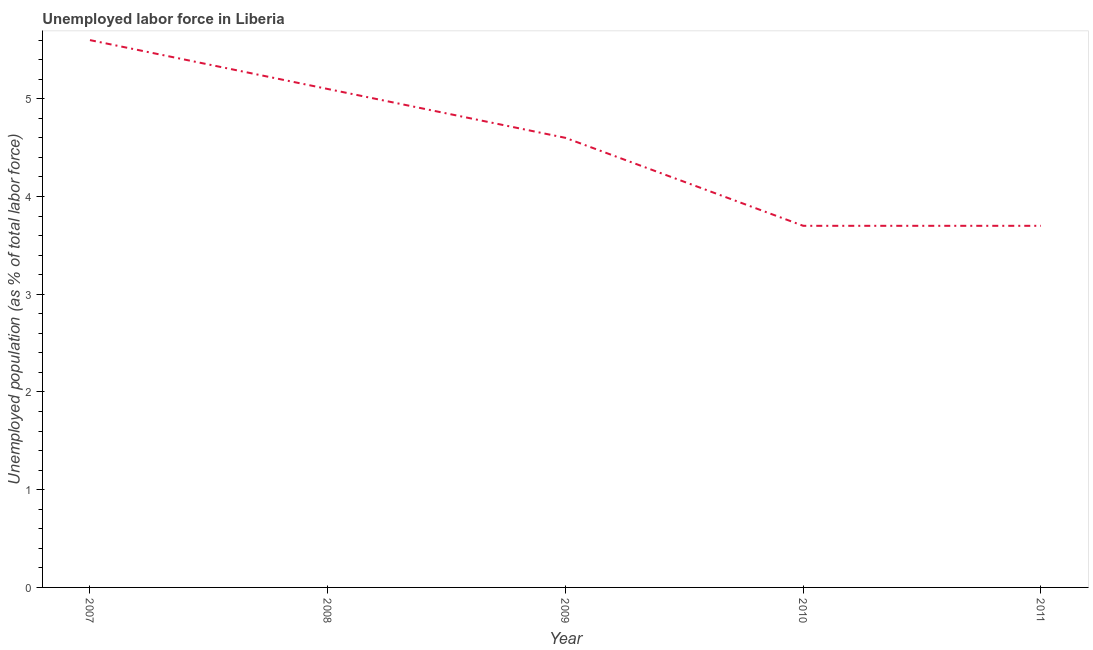What is the total unemployed population in 2009?
Provide a short and direct response. 4.6. Across all years, what is the maximum total unemployed population?
Give a very brief answer. 5.6. Across all years, what is the minimum total unemployed population?
Your answer should be compact. 3.7. What is the sum of the total unemployed population?
Keep it short and to the point. 22.7. What is the difference between the total unemployed population in 2007 and 2009?
Make the answer very short. 1. What is the average total unemployed population per year?
Make the answer very short. 4.54. What is the median total unemployed population?
Ensure brevity in your answer.  4.6. In how many years, is the total unemployed population greater than 4 %?
Your response must be concise. 3. What is the ratio of the total unemployed population in 2007 to that in 2010?
Provide a succinct answer. 1.51. What is the difference between the highest and the second highest total unemployed population?
Provide a short and direct response. 0.5. Is the sum of the total unemployed population in 2010 and 2011 greater than the maximum total unemployed population across all years?
Offer a terse response. Yes. What is the difference between the highest and the lowest total unemployed population?
Your response must be concise. 1.9. In how many years, is the total unemployed population greater than the average total unemployed population taken over all years?
Your response must be concise. 3. Are the values on the major ticks of Y-axis written in scientific E-notation?
Your answer should be compact. No. Does the graph contain grids?
Offer a very short reply. No. What is the title of the graph?
Offer a very short reply. Unemployed labor force in Liberia. What is the label or title of the Y-axis?
Make the answer very short. Unemployed population (as % of total labor force). What is the Unemployed population (as % of total labor force) of 2007?
Your response must be concise. 5.6. What is the Unemployed population (as % of total labor force) in 2008?
Provide a short and direct response. 5.1. What is the Unemployed population (as % of total labor force) of 2009?
Provide a succinct answer. 4.6. What is the Unemployed population (as % of total labor force) of 2010?
Your answer should be compact. 3.7. What is the Unemployed population (as % of total labor force) of 2011?
Your response must be concise. 3.7. What is the difference between the Unemployed population (as % of total labor force) in 2008 and 2010?
Provide a succinct answer. 1.4. What is the difference between the Unemployed population (as % of total labor force) in 2009 and 2010?
Your answer should be very brief. 0.9. What is the ratio of the Unemployed population (as % of total labor force) in 2007 to that in 2008?
Your answer should be very brief. 1.1. What is the ratio of the Unemployed population (as % of total labor force) in 2007 to that in 2009?
Your answer should be compact. 1.22. What is the ratio of the Unemployed population (as % of total labor force) in 2007 to that in 2010?
Offer a terse response. 1.51. What is the ratio of the Unemployed population (as % of total labor force) in 2007 to that in 2011?
Offer a very short reply. 1.51. What is the ratio of the Unemployed population (as % of total labor force) in 2008 to that in 2009?
Offer a terse response. 1.11. What is the ratio of the Unemployed population (as % of total labor force) in 2008 to that in 2010?
Offer a very short reply. 1.38. What is the ratio of the Unemployed population (as % of total labor force) in 2008 to that in 2011?
Your answer should be very brief. 1.38. What is the ratio of the Unemployed population (as % of total labor force) in 2009 to that in 2010?
Your response must be concise. 1.24. What is the ratio of the Unemployed population (as % of total labor force) in 2009 to that in 2011?
Offer a very short reply. 1.24. 